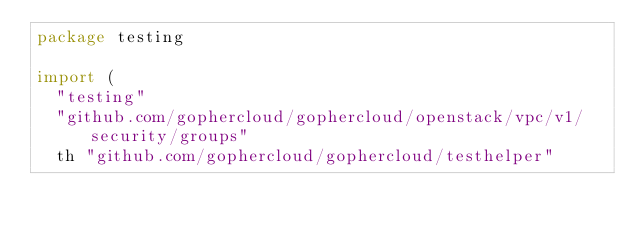<code> <loc_0><loc_0><loc_500><loc_500><_Go_>package testing

import (
	"testing"
	"github.com/gophercloud/gophercloud/openstack/vpc/v1/security/groups"
	th "github.com/gophercloud/gophercloud/testhelper"</code> 